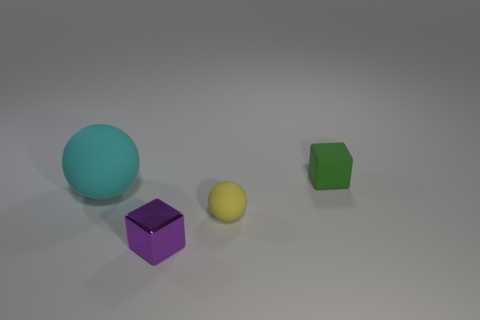Are the tiny purple cube and the sphere right of the large object made of the same material?
Keep it short and to the point. No. There is a purple metallic cube; are there any small green matte objects in front of it?
Offer a terse response. No. How many objects are either tiny green blocks or rubber objects left of the tiny matte block?
Keep it short and to the point. 3. What color is the block that is in front of the matte ball that is in front of the big rubber thing?
Make the answer very short. Purple. What number of other things are the same material as the large cyan object?
Make the answer very short. 2. What number of shiny objects are tiny spheres or big blue things?
Your answer should be compact. 0. What color is the matte object that is the same shape as the purple shiny thing?
Ensure brevity in your answer.  Green. How many things are either small purple metallic blocks or spheres?
Your response must be concise. 3. There is a yellow thing that is the same material as the tiny green block; what shape is it?
Your answer should be very brief. Sphere. How many tiny objects are either objects or red matte objects?
Give a very brief answer. 3. 